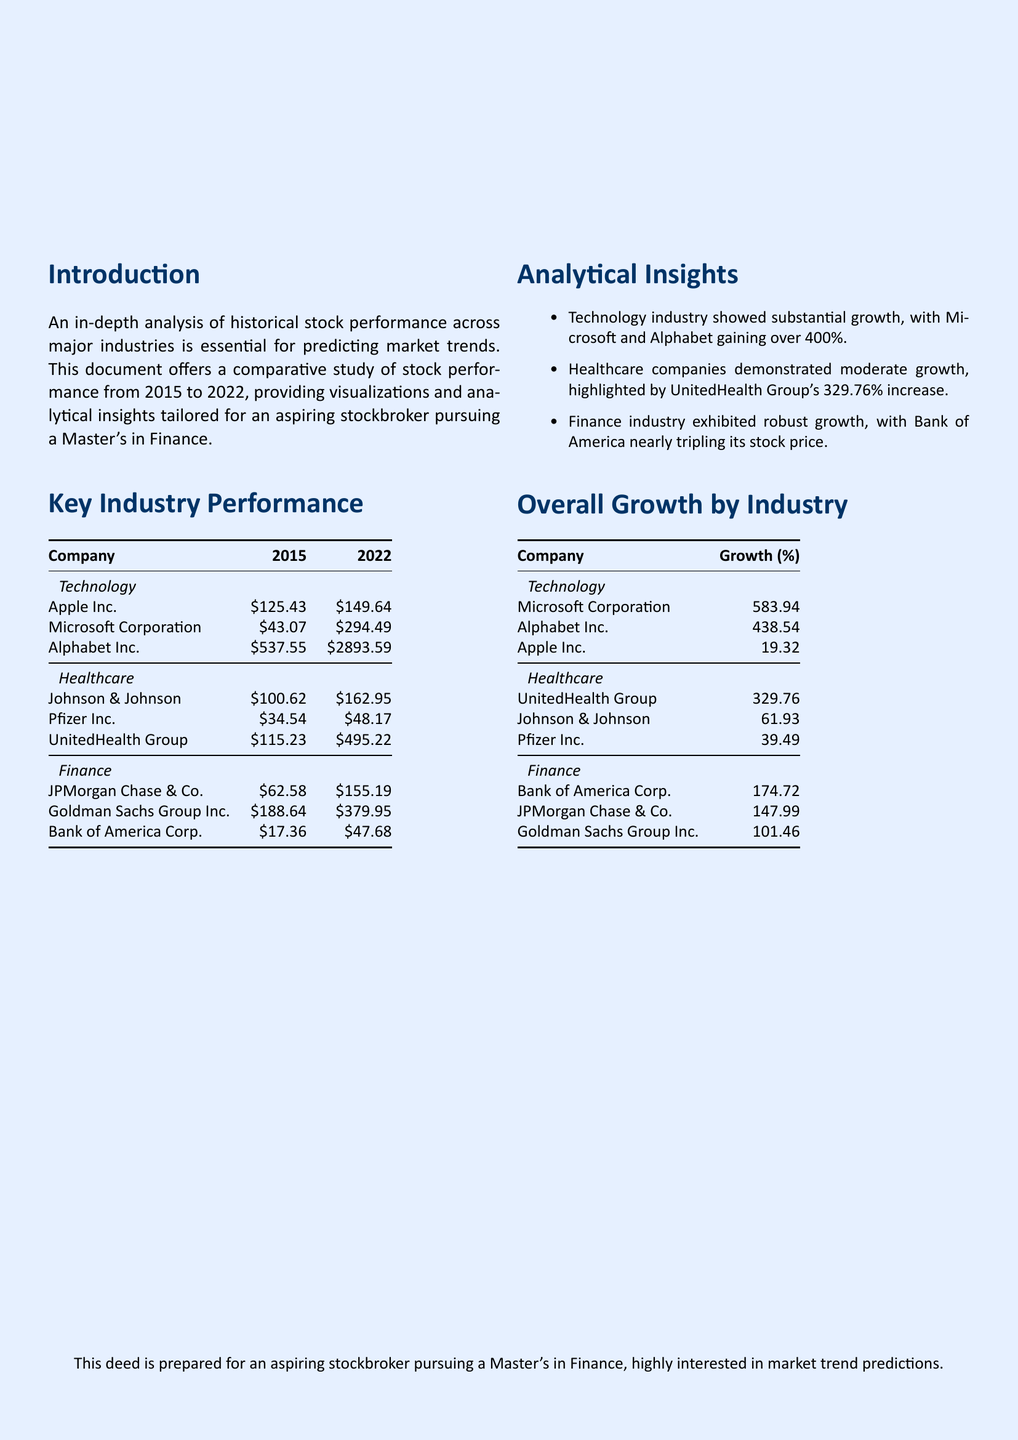What was the stock price of Apple Inc. in 2015? The document provides the stock price of Apple Inc. in 2015, which is $125.43.
Answer: $125.43 Which industry showed the highest overall growth? The overall growth by industry section shows that the Technology industry had the highest growth percentages for its companies.
Answer: Technology What was the percentage growth of UnitedHealth Group? The document states that UnitedHealth Group's growth percentage was 329.76%.
Answer: 329.76 What was Microsoft Corporation's stock price in 2022? The stock performance table for 2022 shows that Microsoft Corporation's stock price was $294.49.
Answer: $294.49 Which company had a stock price of $17.36 in 2015? In the finance section, the table indicates that Bank of America Corp. had a stock price of $17.36 in 2015.
Answer: Bank of America Corp What is the total growth percentage of Apple Inc. from 2015 to 2022? The overall growth by industry section indicates that Apple Inc. had a growth of 19.32%.
Answer: 19.32 How many major industries are analyzed in the document? The introduction and key industry performance sections mention three major industries: Technology, Healthcare, and Finance.
Answer: Three Which company showed nearly a tripling of its stock price? The analysis insights mention that Bank of America nearly tripled its stock price from 2015 to 2022.
Answer: Bank of America What was the stock price of Goldman Sachs Group Inc. in 2022? The key industry performance section provides the stock price of Goldman Sachs Group Inc. in 2022 as $379.95.
Answer: $379.95 